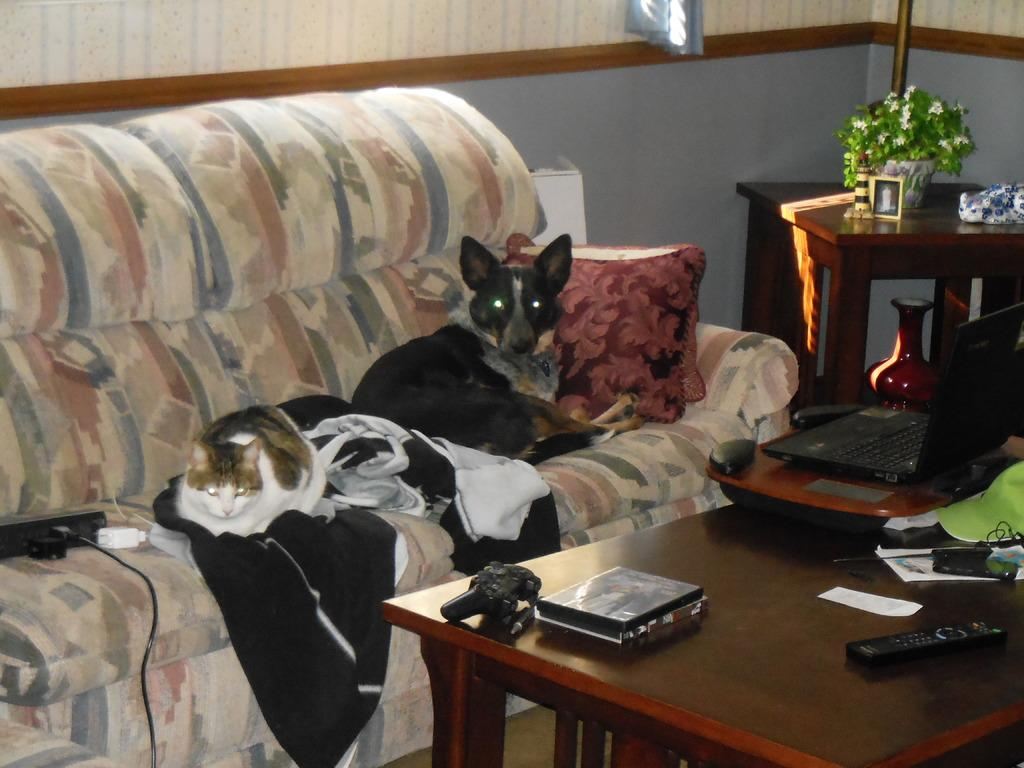What type of space is shown in the image? There is a room in the image. What furniture is present in the room? There is a sofa and a table in the room. What is on the table in the image? There is a cat, a pillow, a laptop, a pen, and paper on the table. What can be seen in the background through the window? There are trees visible in the background through a window. What time of day is it in the image, based on the comparison of the cat's brain to the morning? There is no mention of the time of day or any comparison to the morning in the image. The cat's brain cannot be used to determine the time of day. 